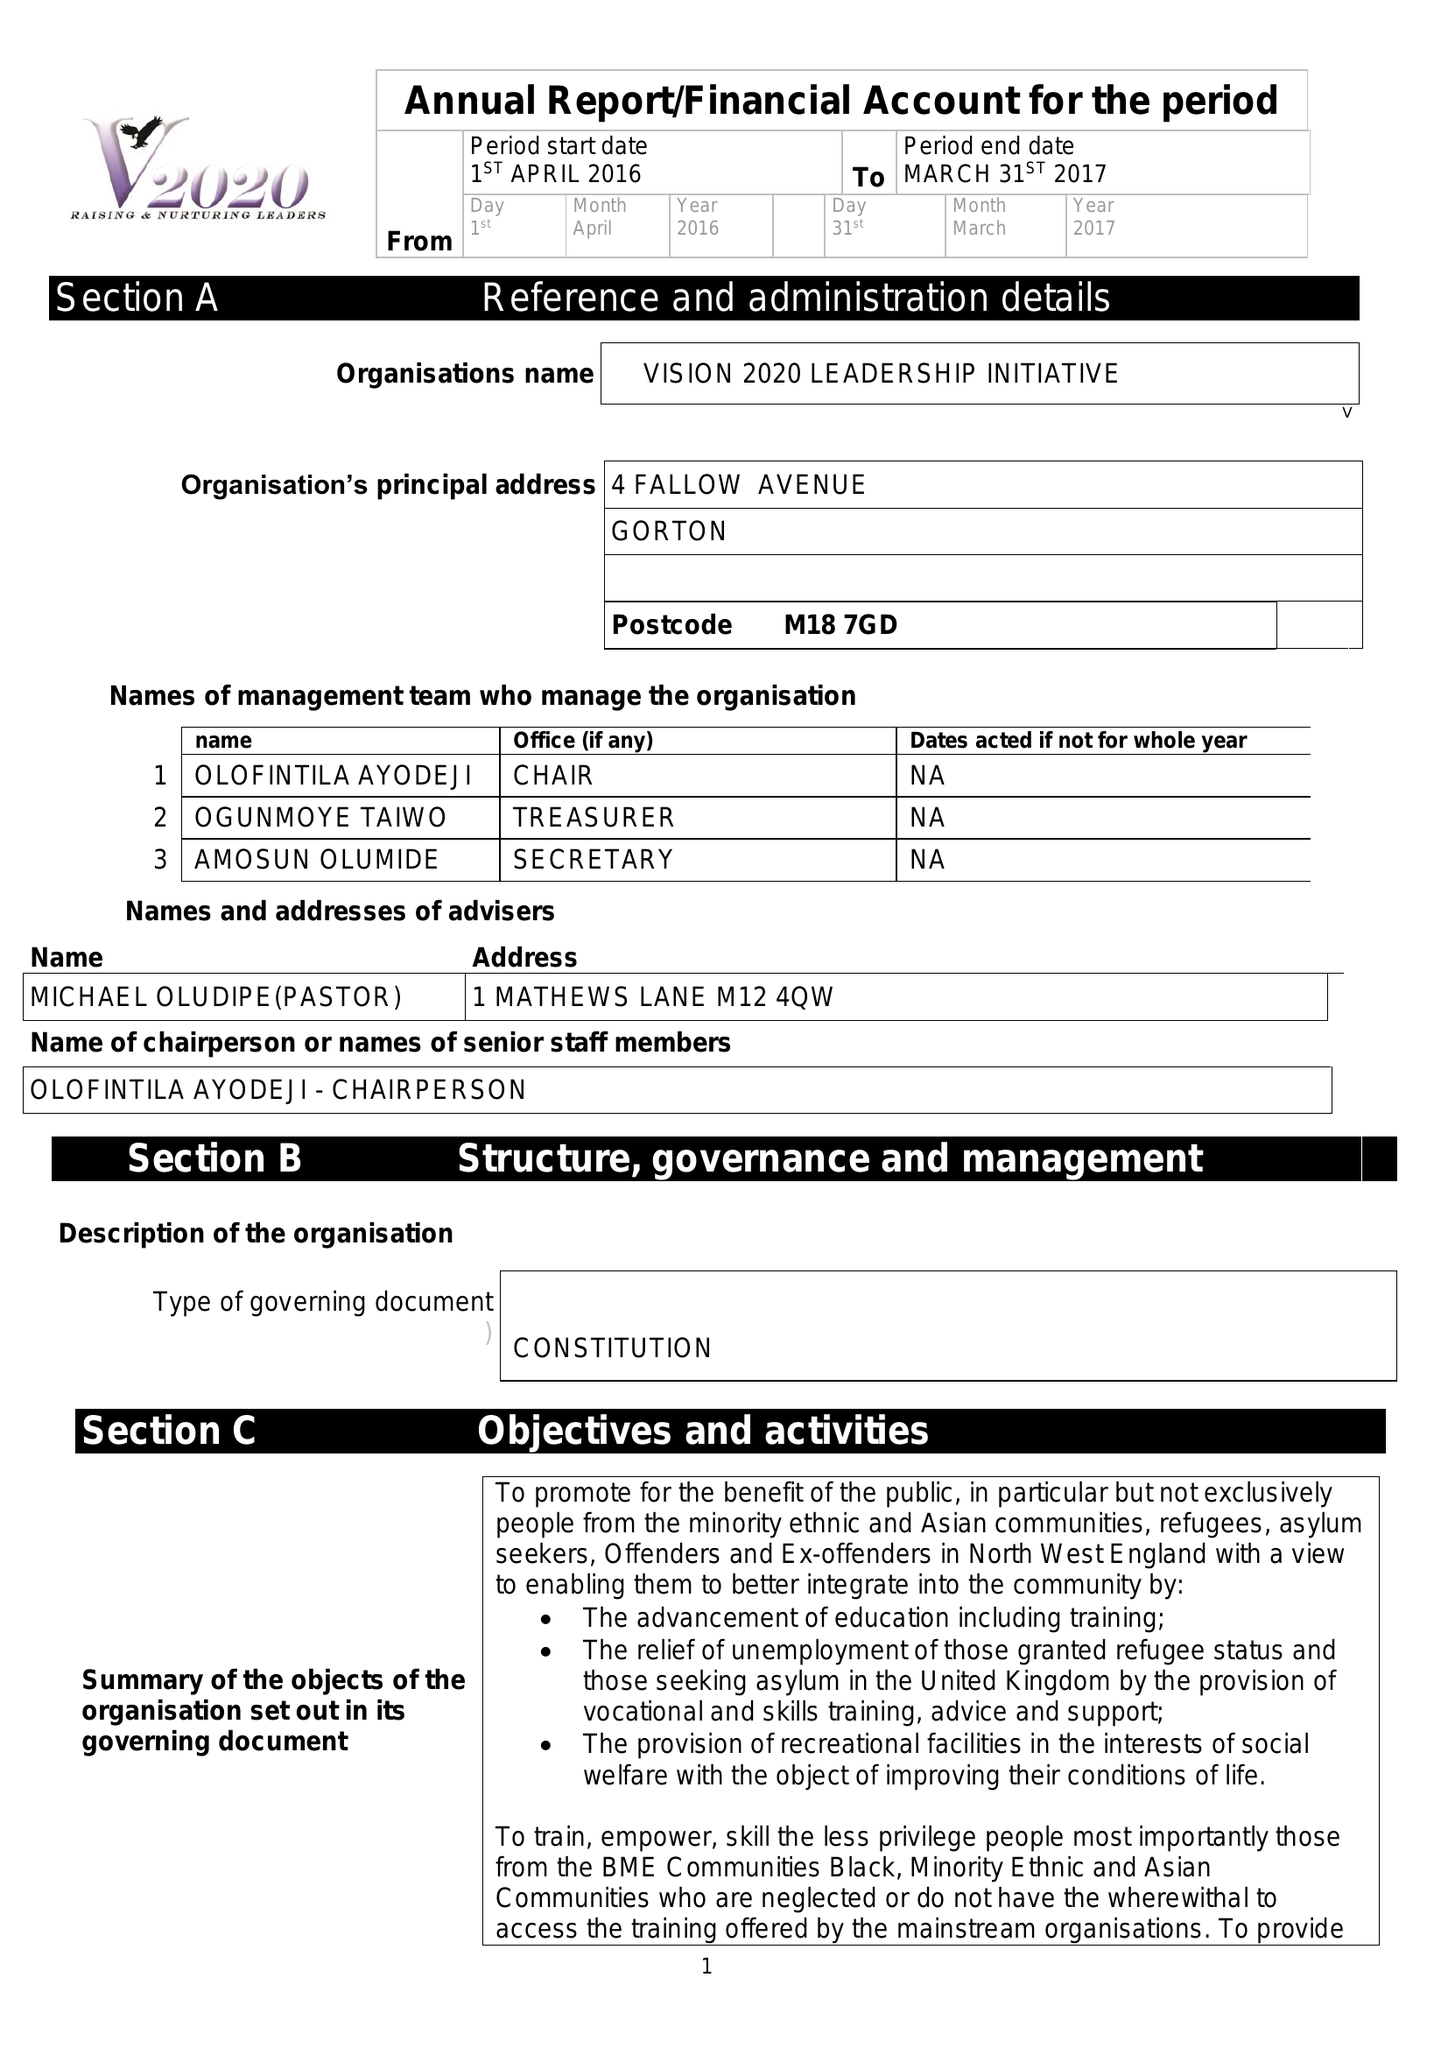What is the value for the address__street_line?
Answer the question using a single word or phrase. 4 FALLOW AVENUE 